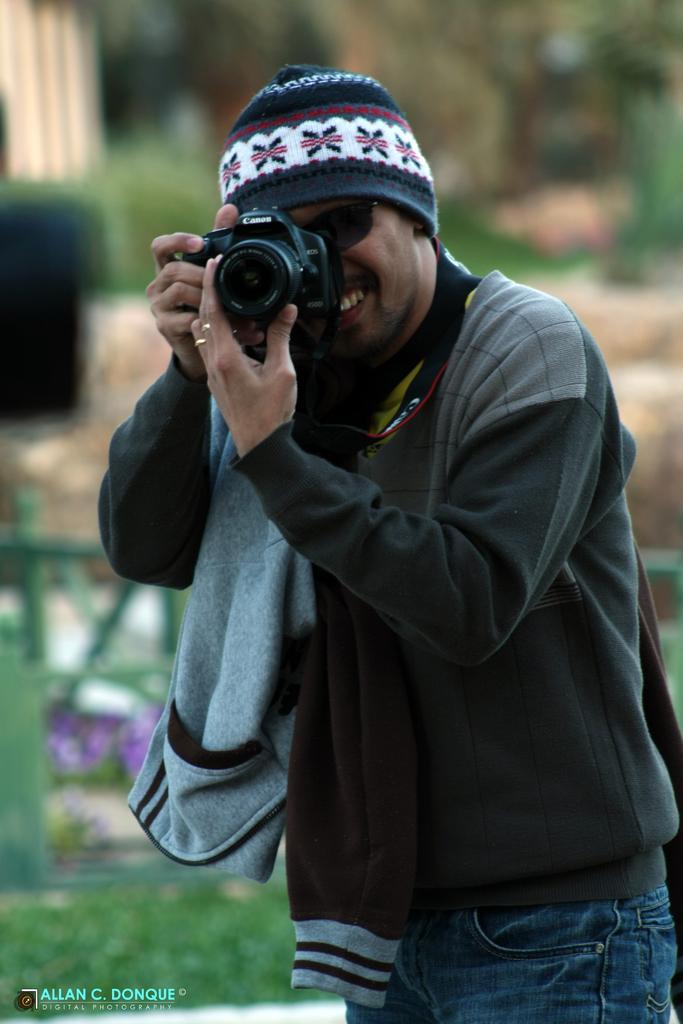Please provide a concise description of this image. Background is blurry. Here we can see one man wearing goggles and a cap holding a camera in his hands and recording. 